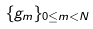<formula> <loc_0><loc_0><loc_500><loc_500>\{ g _ { m } \} _ { 0 \leq m < N }</formula> 